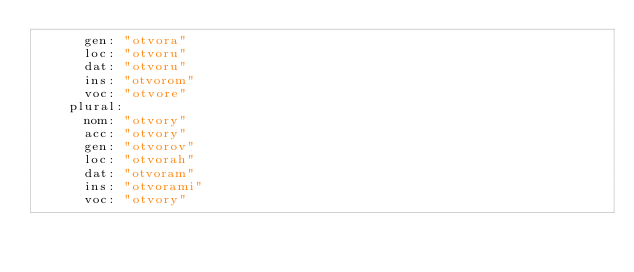Convert code to text. <code><loc_0><loc_0><loc_500><loc_500><_YAML_>      gen: "otvora"
      loc: "otvoru"
      dat: "otvoru"
      ins: "otvorom"
      voc: "otvore"
    plural: 
      nom: "otvory"
      acc: "otvory"
      gen: "otvorov"
      loc: "otvorah"
      dat: "otvoram"
      ins: "otvorami"
      voc: "otvory"
</code> 